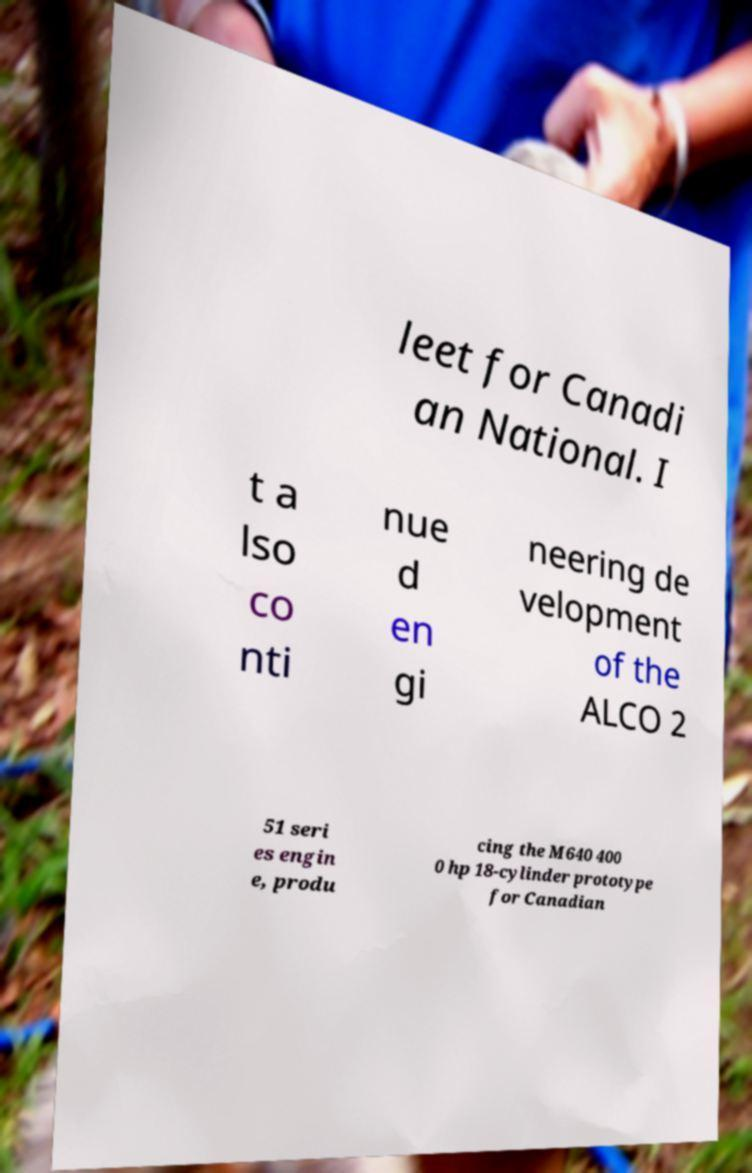There's text embedded in this image that I need extracted. Can you transcribe it verbatim? leet for Canadi an National. I t a lso co nti nue d en gi neering de velopment of the ALCO 2 51 seri es engin e, produ cing the M640 400 0 hp 18-cylinder prototype for Canadian 